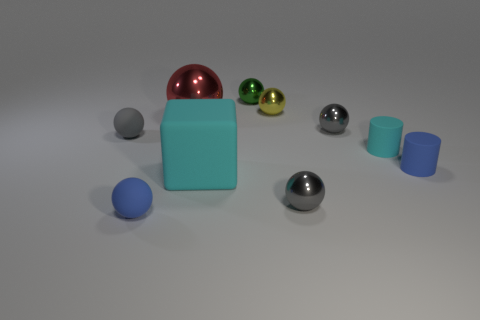Are there the same number of gray metal objects behind the large shiny ball and metallic objects that are to the right of the cyan cube?
Offer a very short reply. No. How many spheres are red things or purple matte objects?
Give a very brief answer. 1. What number of green things have the same material as the large red ball?
Give a very brief answer. 1. There is a thing that is the same color as the block; what is its shape?
Offer a very short reply. Cylinder. The object that is in front of the large block and on the left side of the yellow object is made of what material?
Your answer should be compact. Rubber. What shape is the gray metal object that is behind the big cyan object?
Give a very brief answer. Sphere. What is the shape of the gray metallic thing that is to the right of the gray metal ball in front of the small gray matte thing?
Give a very brief answer. Sphere. Are there any other rubber objects that have the same shape as the small green object?
Keep it short and to the point. Yes. There is a matte object that is the same size as the red ball; what shape is it?
Make the answer very short. Cube. There is a small blue thing that is in front of the cyan cube on the left side of the tiny green metal thing; is there a small object in front of it?
Give a very brief answer. No. 